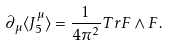<formula> <loc_0><loc_0><loc_500><loc_500>\partial _ { \mu } \langle J _ { 5 } ^ { \mu } \rangle = \frac { 1 } { 4 \pi ^ { 2 } } T r F \wedge F .</formula> 